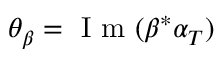<formula> <loc_0><loc_0><loc_500><loc_500>\theta _ { \beta } = I m ( \beta ^ { \ast } \alpha _ { T } )</formula> 